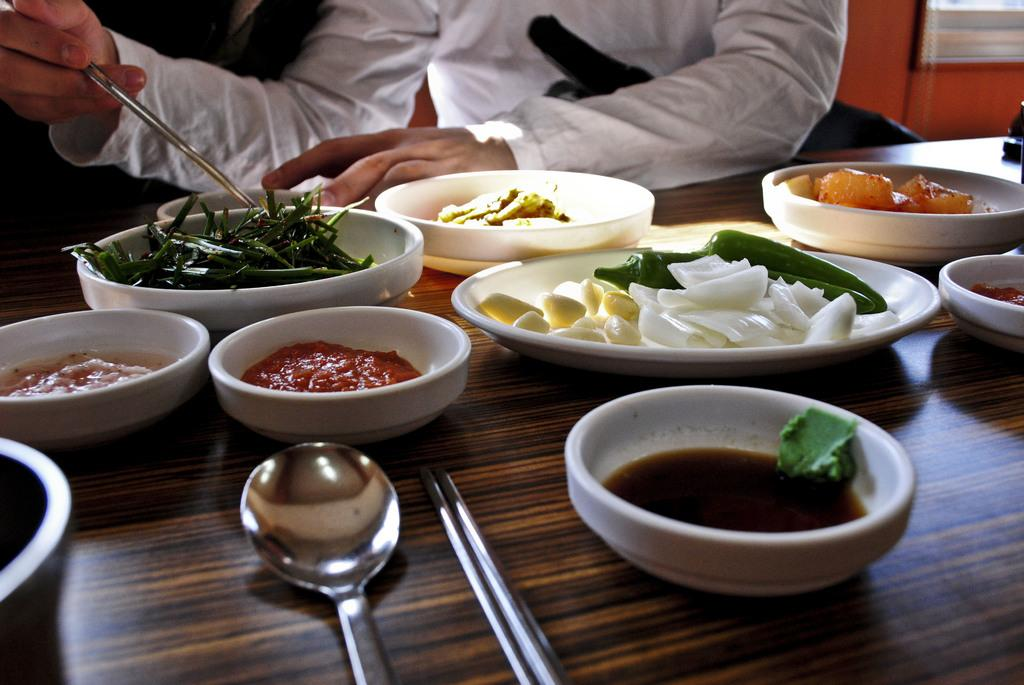What is the person in the image holding? The person is holding some objects in the image. What piece of furniture can be seen in the image? There is a table in the image. What type of food items can be seen on plates in the image? There are plates with food items in the image. What type of food items can be seen in bowls in the image? There are bowls with food items in the image. What utensils are present in the image? There are spoons in the image. What is visible on one side of the image? There is a wall visible in the image. What type of leather material can be seen on the desk in the image? There is no desk present in the image, and therefore no leather material can be observed. How many beans are visible on the plates in the image? There is no mention of beans in the image; the plates contain food items, but the specific items are not specified. 